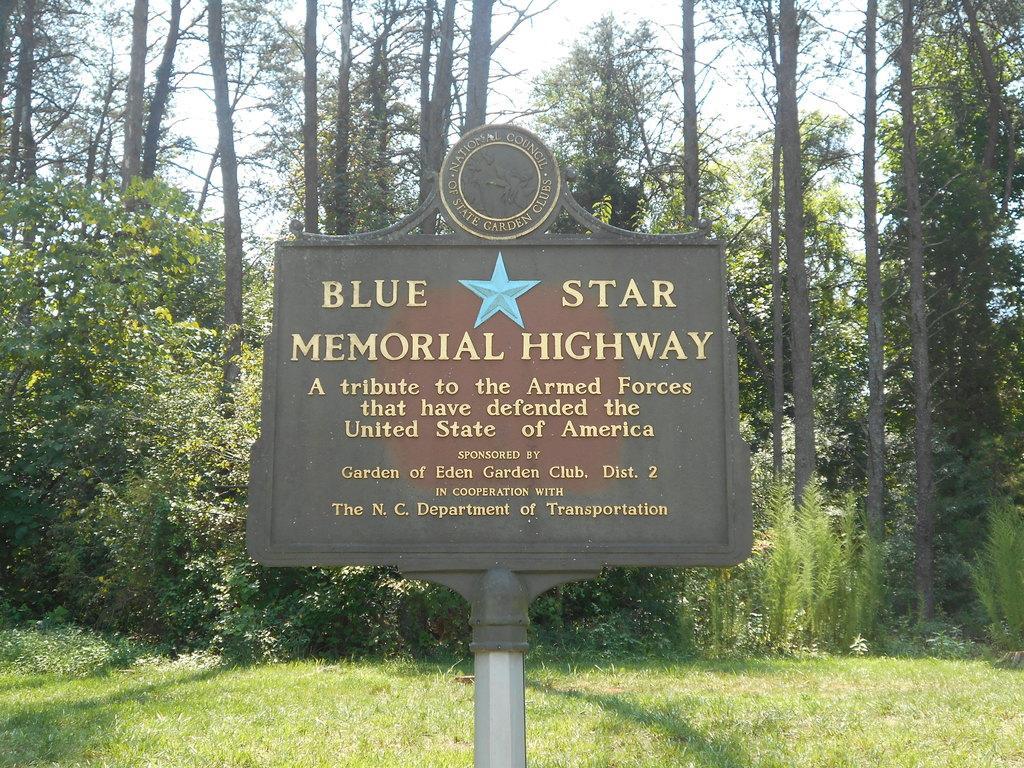How would you summarize this image in a sentence or two? In this image in the foreground there is a board. In the background there are trees, plants and sky. 